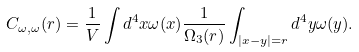<formula> <loc_0><loc_0><loc_500><loc_500>C _ { \omega , \omega } ( r ) = \frac { 1 } { V } \int d ^ { 4 } x \omega ( x ) \frac { 1 } { \Omega _ { 3 } ( r ) } \int _ { | x - y | = r } d ^ { 4 } y \omega ( y ) .</formula> 